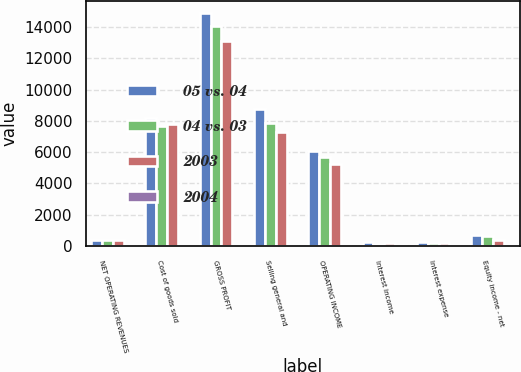Convert chart to OTSL. <chart><loc_0><loc_0><loc_500><loc_500><stacked_bar_chart><ecel><fcel>NET OPERATING REVENUES<fcel>Cost of goods sold<fcel>GROSS PROFIT<fcel>Selling general and<fcel>OPERATING INCOME<fcel>Interest income<fcel>Interest expense<fcel>Equity income - net<nl><fcel>05 vs. 04<fcel>406<fcel>8195<fcel>14909<fcel>8739<fcel>6085<fcel>235<fcel>240<fcel>680<nl><fcel>04 vs. 03<fcel>406<fcel>7674<fcel>14068<fcel>7890<fcel>5698<fcel>157<fcel>196<fcel>621<nl><fcel>2003<fcel>406<fcel>7776<fcel>13081<fcel>7287<fcel>5221<fcel>176<fcel>178<fcel>406<nl><fcel>2004<fcel>6<fcel>7<fcel>6<fcel>11<fcel>7<fcel>50<fcel>22<fcel>10<nl></chart> 